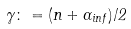<formula> <loc_0><loc_0><loc_500><loc_500>\gamma \colon = ( n + \alpha _ { i n f } ) / 2</formula> 